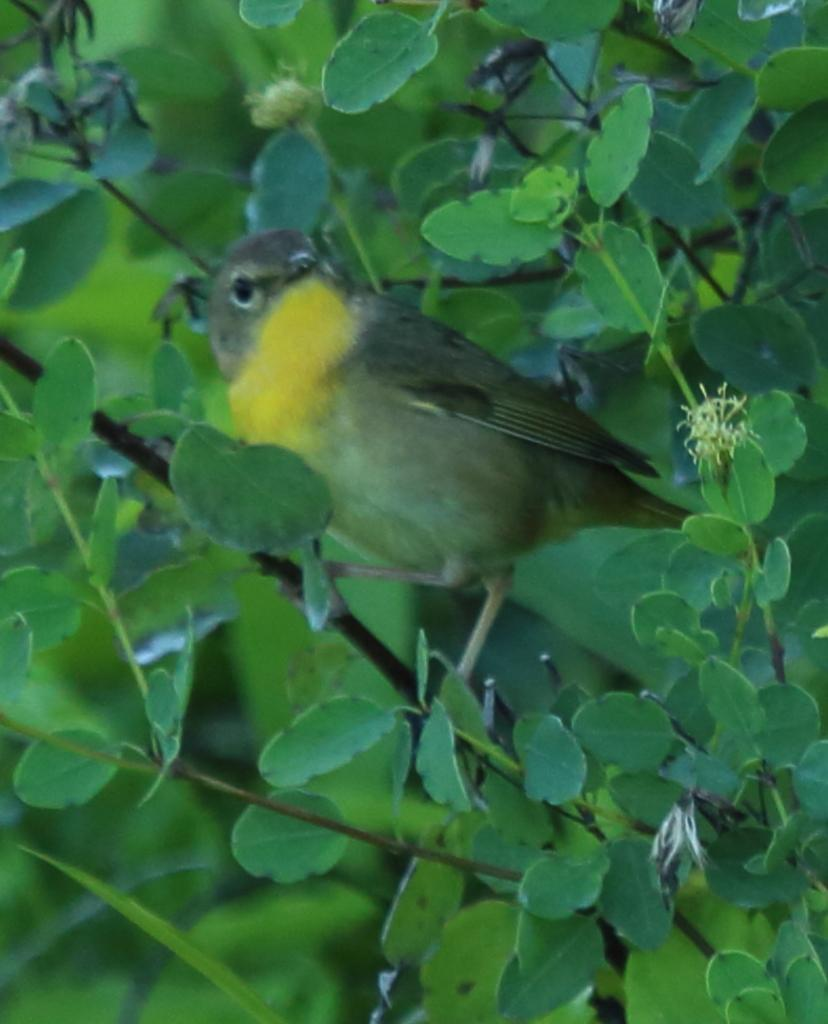What type of animal is in the image? There is a bird in the image. Can you describe the bird's appearance? The bird is brown and yellow in color. Where is the bird located in the image? The bird is on a stem. What else can be seen in the image besides the bird? There are leaves in the image. What type of hook can be seen hanging from the bird's beak in the image? There is no hook present in the image; the bird is simply perched on a stem. What kind of music is the bird playing in the image? There is no music or musical instrument present in the image; it only features a bird on a stem and leaves. 